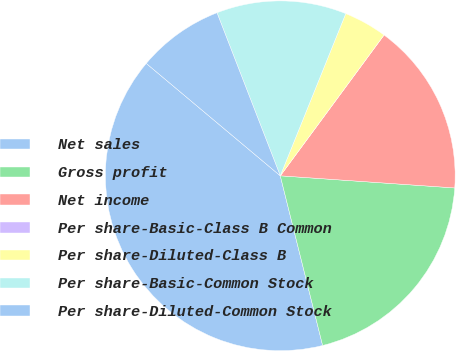Convert chart. <chart><loc_0><loc_0><loc_500><loc_500><pie_chart><fcel>Net sales<fcel>Gross profit<fcel>Net income<fcel>Per share-Basic-Class B Common<fcel>Per share-Diluted-Class B<fcel>Per share-Basic-Common Stock<fcel>Per share-Diluted-Common Stock<nl><fcel>40.0%<fcel>20.0%<fcel>16.0%<fcel>0.0%<fcel>4.0%<fcel>12.0%<fcel>8.0%<nl></chart> 